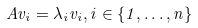<formula> <loc_0><loc_0><loc_500><loc_500>A v _ { i } = \lambda _ { i } v _ { i } , i \in \{ 1 , \dots , n \}</formula> 